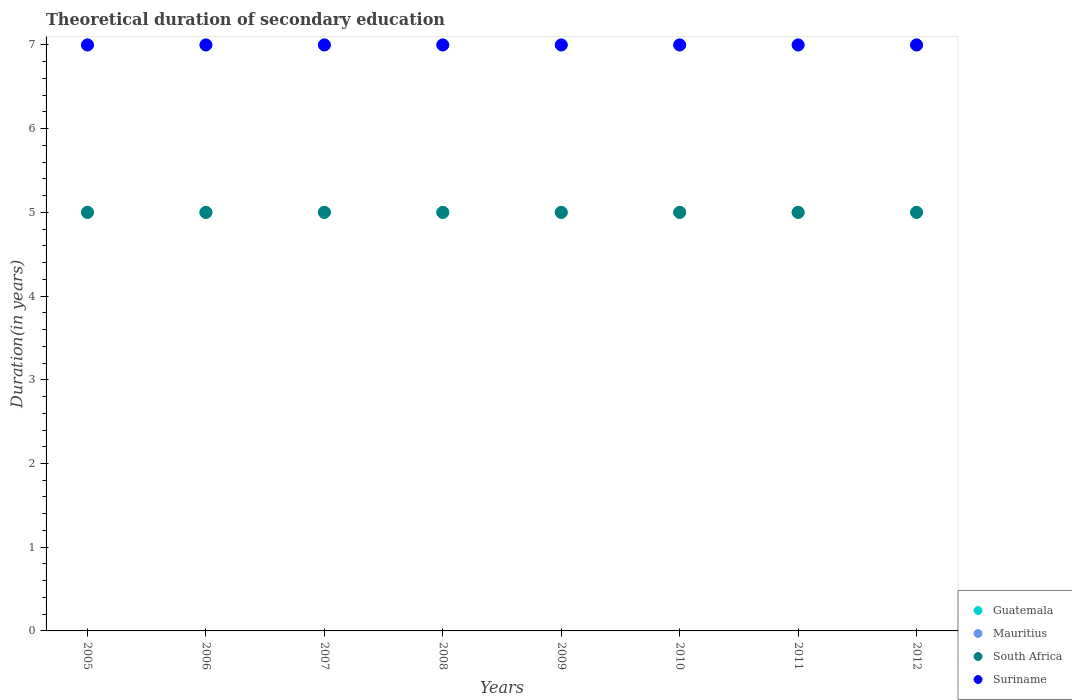What is the total theoretical duration of secondary education in Mauritius in 2012?
Provide a succinct answer. 7. Across all years, what is the maximum total theoretical duration of secondary education in Guatemala?
Make the answer very short. 5. Across all years, what is the minimum total theoretical duration of secondary education in Suriname?
Keep it short and to the point. 7. In which year was the total theoretical duration of secondary education in South Africa maximum?
Provide a succinct answer. 2005. What is the total total theoretical duration of secondary education in Guatemala in the graph?
Your answer should be very brief. 40. What is the difference between the total theoretical duration of secondary education in Guatemala in 2012 and the total theoretical duration of secondary education in Mauritius in 2009?
Ensure brevity in your answer.  -2. In the year 2011, what is the difference between the total theoretical duration of secondary education in Mauritius and total theoretical duration of secondary education in Guatemala?
Keep it short and to the point. 2. In how many years, is the total theoretical duration of secondary education in South Africa greater than 5.8 years?
Keep it short and to the point. 0. What is the ratio of the total theoretical duration of secondary education in Mauritius in 2005 to that in 2007?
Provide a succinct answer. 1. Is the total theoretical duration of secondary education in Guatemala in 2006 less than that in 2010?
Your answer should be compact. No. Is the difference between the total theoretical duration of secondary education in Mauritius in 2008 and 2009 greater than the difference between the total theoretical duration of secondary education in Guatemala in 2008 and 2009?
Keep it short and to the point. No. What is the difference between the highest and the second highest total theoretical duration of secondary education in Suriname?
Offer a terse response. 0. What is the difference between the highest and the lowest total theoretical duration of secondary education in Suriname?
Keep it short and to the point. 0. Is it the case that in every year, the sum of the total theoretical duration of secondary education in Suriname and total theoretical duration of secondary education in South Africa  is greater than the sum of total theoretical duration of secondary education in Mauritius and total theoretical duration of secondary education in Guatemala?
Give a very brief answer. Yes. Does the total theoretical duration of secondary education in South Africa monotonically increase over the years?
Your response must be concise. No. Is the total theoretical duration of secondary education in South Africa strictly less than the total theoretical duration of secondary education in Guatemala over the years?
Offer a terse response. No. How many dotlines are there?
Keep it short and to the point. 4. Are the values on the major ticks of Y-axis written in scientific E-notation?
Your answer should be compact. No. Where does the legend appear in the graph?
Your answer should be very brief. Bottom right. How many legend labels are there?
Your response must be concise. 4. How are the legend labels stacked?
Your response must be concise. Vertical. What is the title of the graph?
Ensure brevity in your answer.  Theoretical duration of secondary education. What is the label or title of the X-axis?
Give a very brief answer. Years. What is the label or title of the Y-axis?
Provide a succinct answer. Duration(in years). What is the Duration(in years) of Guatemala in 2005?
Keep it short and to the point. 5. What is the Duration(in years) of Guatemala in 2006?
Ensure brevity in your answer.  5. What is the Duration(in years) of Guatemala in 2007?
Ensure brevity in your answer.  5. What is the Duration(in years) of Mauritius in 2008?
Keep it short and to the point. 7. What is the Duration(in years) of South Africa in 2008?
Offer a very short reply. 5. What is the Duration(in years) of Guatemala in 2009?
Your response must be concise. 5. What is the Duration(in years) in South Africa in 2010?
Give a very brief answer. 5. What is the Duration(in years) of Guatemala in 2011?
Your response must be concise. 5. What is the Duration(in years) of South Africa in 2011?
Provide a succinct answer. 5. What is the Duration(in years) of Guatemala in 2012?
Your answer should be very brief. 5. What is the Duration(in years) in Mauritius in 2012?
Your answer should be compact. 7. Across all years, what is the maximum Duration(in years) in Guatemala?
Ensure brevity in your answer.  5. Across all years, what is the maximum Duration(in years) in Suriname?
Your answer should be compact. 7. Across all years, what is the minimum Duration(in years) in Guatemala?
Make the answer very short. 5. Across all years, what is the minimum Duration(in years) of Mauritius?
Ensure brevity in your answer.  7. Across all years, what is the minimum Duration(in years) of South Africa?
Provide a succinct answer. 5. What is the total Duration(in years) in Guatemala in the graph?
Offer a very short reply. 40. What is the total Duration(in years) of Mauritius in the graph?
Provide a succinct answer. 56. What is the total Duration(in years) in South Africa in the graph?
Offer a terse response. 40. What is the total Duration(in years) of Suriname in the graph?
Keep it short and to the point. 56. What is the difference between the Duration(in years) in Guatemala in 2005 and that in 2006?
Provide a short and direct response. 0. What is the difference between the Duration(in years) in Mauritius in 2005 and that in 2006?
Your answer should be compact. 0. What is the difference between the Duration(in years) of South Africa in 2005 and that in 2006?
Your response must be concise. 0. What is the difference between the Duration(in years) in Suriname in 2005 and that in 2006?
Provide a short and direct response. 0. What is the difference between the Duration(in years) in Guatemala in 2005 and that in 2007?
Your response must be concise. 0. What is the difference between the Duration(in years) of Mauritius in 2005 and that in 2007?
Offer a terse response. 0. What is the difference between the Duration(in years) in South Africa in 2005 and that in 2008?
Give a very brief answer. 0. What is the difference between the Duration(in years) of Suriname in 2005 and that in 2008?
Offer a very short reply. 0. What is the difference between the Duration(in years) in Guatemala in 2005 and that in 2009?
Keep it short and to the point. 0. What is the difference between the Duration(in years) in South Africa in 2005 and that in 2009?
Provide a short and direct response. 0. What is the difference between the Duration(in years) of Suriname in 2005 and that in 2009?
Give a very brief answer. 0. What is the difference between the Duration(in years) in Suriname in 2005 and that in 2010?
Your answer should be compact. 0. What is the difference between the Duration(in years) in South Africa in 2005 and that in 2011?
Provide a succinct answer. 0. What is the difference between the Duration(in years) of Mauritius in 2005 and that in 2012?
Offer a terse response. 0. What is the difference between the Duration(in years) of Suriname in 2005 and that in 2012?
Offer a very short reply. 0. What is the difference between the Duration(in years) of Guatemala in 2006 and that in 2007?
Your answer should be very brief. 0. What is the difference between the Duration(in years) of South Africa in 2006 and that in 2007?
Make the answer very short. 0. What is the difference between the Duration(in years) of Suriname in 2006 and that in 2007?
Ensure brevity in your answer.  0. What is the difference between the Duration(in years) of Guatemala in 2006 and that in 2008?
Offer a terse response. 0. What is the difference between the Duration(in years) in Mauritius in 2006 and that in 2008?
Ensure brevity in your answer.  0. What is the difference between the Duration(in years) in Suriname in 2006 and that in 2008?
Ensure brevity in your answer.  0. What is the difference between the Duration(in years) in Guatemala in 2006 and that in 2009?
Provide a succinct answer. 0. What is the difference between the Duration(in years) in South Africa in 2006 and that in 2009?
Your answer should be very brief. 0. What is the difference between the Duration(in years) in Suriname in 2006 and that in 2009?
Ensure brevity in your answer.  0. What is the difference between the Duration(in years) in Suriname in 2006 and that in 2010?
Provide a short and direct response. 0. What is the difference between the Duration(in years) in Guatemala in 2006 and that in 2011?
Keep it short and to the point. 0. What is the difference between the Duration(in years) of Mauritius in 2006 and that in 2011?
Offer a terse response. 0. What is the difference between the Duration(in years) of South Africa in 2006 and that in 2011?
Offer a very short reply. 0. What is the difference between the Duration(in years) of Suriname in 2006 and that in 2011?
Your answer should be very brief. 0. What is the difference between the Duration(in years) in Guatemala in 2006 and that in 2012?
Offer a very short reply. 0. What is the difference between the Duration(in years) in Suriname in 2006 and that in 2012?
Provide a short and direct response. 0. What is the difference between the Duration(in years) in Guatemala in 2007 and that in 2008?
Your response must be concise. 0. What is the difference between the Duration(in years) in Mauritius in 2007 and that in 2008?
Give a very brief answer. 0. What is the difference between the Duration(in years) in Suriname in 2007 and that in 2008?
Ensure brevity in your answer.  0. What is the difference between the Duration(in years) of Guatemala in 2007 and that in 2010?
Your answer should be compact. 0. What is the difference between the Duration(in years) in Mauritius in 2007 and that in 2010?
Your response must be concise. 0. What is the difference between the Duration(in years) in Suriname in 2007 and that in 2011?
Keep it short and to the point. 0. What is the difference between the Duration(in years) in Guatemala in 2007 and that in 2012?
Keep it short and to the point. 0. What is the difference between the Duration(in years) of Suriname in 2007 and that in 2012?
Offer a terse response. 0. What is the difference between the Duration(in years) of Guatemala in 2008 and that in 2009?
Your answer should be compact. 0. What is the difference between the Duration(in years) of Mauritius in 2008 and that in 2009?
Offer a terse response. 0. What is the difference between the Duration(in years) of South Africa in 2008 and that in 2009?
Provide a succinct answer. 0. What is the difference between the Duration(in years) in Guatemala in 2008 and that in 2010?
Your answer should be compact. 0. What is the difference between the Duration(in years) of Mauritius in 2008 and that in 2010?
Make the answer very short. 0. What is the difference between the Duration(in years) in Mauritius in 2008 and that in 2011?
Keep it short and to the point. 0. What is the difference between the Duration(in years) of South Africa in 2008 and that in 2011?
Your answer should be compact. 0. What is the difference between the Duration(in years) of Guatemala in 2008 and that in 2012?
Your answer should be very brief. 0. What is the difference between the Duration(in years) of South Africa in 2008 and that in 2012?
Offer a very short reply. 0. What is the difference between the Duration(in years) in Suriname in 2008 and that in 2012?
Your response must be concise. 0. What is the difference between the Duration(in years) in Mauritius in 2009 and that in 2010?
Provide a succinct answer. 0. What is the difference between the Duration(in years) in South Africa in 2009 and that in 2010?
Give a very brief answer. 0. What is the difference between the Duration(in years) in Guatemala in 2009 and that in 2011?
Make the answer very short. 0. What is the difference between the Duration(in years) of Mauritius in 2009 and that in 2011?
Give a very brief answer. 0. What is the difference between the Duration(in years) in Suriname in 2009 and that in 2011?
Offer a very short reply. 0. What is the difference between the Duration(in years) in South Africa in 2009 and that in 2012?
Offer a very short reply. 0. What is the difference between the Duration(in years) of Suriname in 2009 and that in 2012?
Provide a succinct answer. 0. What is the difference between the Duration(in years) of Guatemala in 2010 and that in 2011?
Keep it short and to the point. 0. What is the difference between the Duration(in years) of Mauritius in 2010 and that in 2011?
Your answer should be very brief. 0. What is the difference between the Duration(in years) in Mauritius in 2010 and that in 2012?
Offer a very short reply. 0. What is the difference between the Duration(in years) in Guatemala in 2011 and that in 2012?
Provide a short and direct response. 0. What is the difference between the Duration(in years) in South Africa in 2011 and that in 2012?
Give a very brief answer. 0. What is the difference between the Duration(in years) of Suriname in 2011 and that in 2012?
Offer a very short reply. 0. What is the difference between the Duration(in years) of Guatemala in 2005 and the Duration(in years) of Mauritius in 2006?
Ensure brevity in your answer.  -2. What is the difference between the Duration(in years) of Guatemala in 2005 and the Duration(in years) of Suriname in 2006?
Give a very brief answer. -2. What is the difference between the Duration(in years) in Mauritius in 2005 and the Duration(in years) in South Africa in 2006?
Make the answer very short. 2. What is the difference between the Duration(in years) of Mauritius in 2005 and the Duration(in years) of Suriname in 2006?
Give a very brief answer. 0. What is the difference between the Duration(in years) in South Africa in 2005 and the Duration(in years) in Suriname in 2006?
Make the answer very short. -2. What is the difference between the Duration(in years) in Guatemala in 2005 and the Duration(in years) in Mauritius in 2007?
Your answer should be very brief. -2. What is the difference between the Duration(in years) of Guatemala in 2005 and the Duration(in years) of Suriname in 2007?
Give a very brief answer. -2. What is the difference between the Duration(in years) of South Africa in 2005 and the Duration(in years) of Suriname in 2007?
Provide a short and direct response. -2. What is the difference between the Duration(in years) in South Africa in 2005 and the Duration(in years) in Suriname in 2008?
Provide a short and direct response. -2. What is the difference between the Duration(in years) of Guatemala in 2005 and the Duration(in years) of Mauritius in 2009?
Your response must be concise. -2. What is the difference between the Duration(in years) in Guatemala in 2005 and the Duration(in years) in South Africa in 2009?
Make the answer very short. 0. What is the difference between the Duration(in years) of Guatemala in 2005 and the Duration(in years) of Suriname in 2009?
Make the answer very short. -2. What is the difference between the Duration(in years) in Mauritius in 2005 and the Duration(in years) in Suriname in 2009?
Provide a short and direct response. 0. What is the difference between the Duration(in years) of Guatemala in 2005 and the Duration(in years) of Mauritius in 2010?
Give a very brief answer. -2. What is the difference between the Duration(in years) of Mauritius in 2005 and the Duration(in years) of Suriname in 2010?
Keep it short and to the point. 0. What is the difference between the Duration(in years) in South Africa in 2005 and the Duration(in years) in Suriname in 2010?
Provide a short and direct response. -2. What is the difference between the Duration(in years) in Guatemala in 2005 and the Duration(in years) in Mauritius in 2011?
Ensure brevity in your answer.  -2. What is the difference between the Duration(in years) of Mauritius in 2005 and the Duration(in years) of South Africa in 2011?
Keep it short and to the point. 2. What is the difference between the Duration(in years) in South Africa in 2005 and the Duration(in years) in Suriname in 2011?
Offer a very short reply. -2. What is the difference between the Duration(in years) of Guatemala in 2005 and the Duration(in years) of Mauritius in 2012?
Your answer should be very brief. -2. What is the difference between the Duration(in years) in Mauritius in 2005 and the Duration(in years) in South Africa in 2012?
Your answer should be compact. 2. What is the difference between the Duration(in years) in South Africa in 2005 and the Duration(in years) in Suriname in 2012?
Offer a terse response. -2. What is the difference between the Duration(in years) of Guatemala in 2006 and the Duration(in years) of Mauritius in 2007?
Offer a terse response. -2. What is the difference between the Duration(in years) in Mauritius in 2006 and the Duration(in years) in South Africa in 2007?
Your answer should be very brief. 2. What is the difference between the Duration(in years) in Guatemala in 2006 and the Duration(in years) in Mauritius in 2008?
Offer a terse response. -2. What is the difference between the Duration(in years) of Guatemala in 2006 and the Duration(in years) of South Africa in 2008?
Offer a terse response. 0. What is the difference between the Duration(in years) of Guatemala in 2006 and the Duration(in years) of Suriname in 2008?
Offer a terse response. -2. What is the difference between the Duration(in years) in Mauritius in 2006 and the Duration(in years) in South Africa in 2008?
Your answer should be compact. 2. What is the difference between the Duration(in years) in Mauritius in 2006 and the Duration(in years) in Suriname in 2008?
Offer a very short reply. 0. What is the difference between the Duration(in years) of South Africa in 2006 and the Duration(in years) of Suriname in 2008?
Your answer should be compact. -2. What is the difference between the Duration(in years) in Guatemala in 2006 and the Duration(in years) in South Africa in 2009?
Your answer should be compact. 0. What is the difference between the Duration(in years) in Guatemala in 2006 and the Duration(in years) in Suriname in 2009?
Your answer should be very brief. -2. What is the difference between the Duration(in years) in Mauritius in 2006 and the Duration(in years) in South Africa in 2009?
Ensure brevity in your answer.  2. What is the difference between the Duration(in years) in Mauritius in 2006 and the Duration(in years) in Suriname in 2009?
Provide a short and direct response. 0. What is the difference between the Duration(in years) in Guatemala in 2006 and the Duration(in years) in Mauritius in 2010?
Offer a terse response. -2. What is the difference between the Duration(in years) in Guatemala in 2006 and the Duration(in years) in South Africa in 2010?
Provide a short and direct response. 0. What is the difference between the Duration(in years) in Guatemala in 2006 and the Duration(in years) in Suriname in 2010?
Your answer should be very brief. -2. What is the difference between the Duration(in years) in Mauritius in 2006 and the Duration(in years) in Suriname in 2010?
Offer a terse response. 0. What is the difference between the Duration(in years) in Guatemala in 2006 and the Duration(in years) in South Africa in 2011?
Make the answer very short. 0. What is the difference between the Duration(in years) in Guatemala in 2006 and the Duration(in years) in Suriname in 2011?
Make the answer very short. -2. What is the difference between the Duration(in years) in Mauritius in 2006 and the Duration(in years) in South Africa in 2011?
Provide a succinct answer. 2. What is the difference between the Duration(in years) of Guatemala in 2006 and the Duration(in years) of South Africa in 2012?
Give a very brief answer. 0. What is the difference between the Duration(in years) of Guatemala in 2006 and the Duration(in years) of Suriname in 2012?
Provide a short and direct response. -2. What is the difference between the Duration(in years) of Mauritius in 2006 and the Duration(in years) of South Africa in 2012?
Provide a succinct answer. 2. What is the difference between the Duration(in years) of Guatemala in 2007 and the Duration(in years) of South Africa in 2008?
Keep it short and to the point. 0. What is the difference between the Duration(in years) of Mauritius in 2007 and the Duration(in years) of South Africa in 2008?
Your answer should be compact. 2. What is the difference between the Duration(in years) in South Africa in 2007 and the Duration(in years) in Suriname in 2008?
Your response must be concise. -2. What is the difference between the Duration(in years) of Guatemala in 2007 and the Duration(in years) of South Africa in 2009?
Ensure brevity in your answer.  0. What is the difference between the Duration(in years) in Guatemala in 2007 and the Duration(in years) in Suriname in 2009?
Offer a terse response. -2. What is the difference between the Duration(in years) of South Africa in 2007 and the Duration(in years) of Suriname in 2009?
Your answer should be compact. -2. What is the difference between the Duration(in years) of Guatemala in 2007 and the Duration(in years) of Suriname in 2010?
Your answer should be compact. -2. What is the difference between the Duration(in years) of Mauritius in 2007 and the Duration(in years) of South Africa in 2010?
Offer a terse response. 2. What is the difference between the Duration(in years) in South Africa in 2007 and the Duration(in years) in Suriname in 2010?
Ensure brevity in your answer.  -2. What is the difference between the Duration(in years) in Guatemala in 2007 and the Duration(in years) in South Africa in 2011?
Make the answer very short. 0. What is the difference between the Duration(in years) in Mauritius in 2007 and the Duration(in years) in South Africa in 2011?
Make the answer very short. 2. What is the difference between the Duration(in years) in Mauritius in 2007 and the Duration(in years) in Suriname in 2011?
Offer a terse response. 0. What is the difference between the Duration(in years) in South Africa in 2007 and the Duration(in years) in Suriname in 2011?
Your answer should be compact. -2. What is the difference between the Duration(in years) in Guatemala in 2007 and the Duration(in years) in Mauritius in 2012?
Give a very brief answer. -2. What is the difference between the Duration(in years) of Guatemala in 2007 and the Duration(in years) of South Africa in 2012?
Keep it short and to the point. 0. What is the difference between the Duration(in years) of Guatemala in 2007 and the Duration(in years) of Suriname in 2012?
Offer a very short reply. -2. What is the difference between the Duration(in years) of Guatemala in 2008 and the Duration(in years) of South Africa in 2009?
Make the answer very short. 0. What is the difference between the Duration(in years) in Guatemala in 2008 and the Duration(in years) in Mauritius in 2010?
Provide a succinct answer. -2. What is the difference between the Duration(in years) in Mauritius in 2008 and the Duration(in years) in Suriname in 2010?
Ensure brevity in your answer.  0. What is the difference between the Duration(in years) in Guatemala in 2008 and the Duration(in years) in South Africa in 2011?
Offer a terse response. 0. What is the difference between the Duration(in years) of Mauritius in 2008 and the Duration(in years) of Suriname in 2011?
Provide a short and direct response. 0. What is the difference between the Duration(in years) of South Africa in 2008 and the Duration(in years) of Suriname in 2011?
Your answer should be compact. -2. What is the difference between the Duration(in years) in Guatemala in 2008 and the Duration(in years) in Mauritius in 2012?
Your response must be concise. -2. What is the difference between the Duration(in years) in South Africa in 2008 and the Duration(in years) in Suriname in 2012?
Give a very brief answer. -2. What is the difference between the Duration(in years) in Guatemala in 2009 and the Duration(in years) in South Africa in 2010?
Provide a succinct answer. 0. What is the difference between the Duration(in years) of Guatemala in 2009 and the Duration(in years) of Suriname in 2010?
Keep it short and to the point. -2. What is the difference between the Duration(in years) of Mauritius in 2009 and the Duration(in years) of South Africa in 2010?
Make the answer very short. 2. What is the difference between the Duration(in years) of South Africa in 2009 and the Duration(in years) of Suriname in 2010?
Provide a succinct answer. -2. What is the difference between the Duration(in years) in Guatemala in 2009 and the Duration(in years) in Mauritius in 2011?
Your response must be concise. -2. What is the difference between the Duration(in years) of Guatemala in 2009 and the Duration(in years) of Suriname in 2011?
Your answer should be very brief. -2. What is the difference between the Duration(in years) of Mauritius in 2009 and the Duration(in years) of Suriname in 2011?
Offer a terse response. 0. What is the difference between the Duration(in years) of Guatemala in 2009 and the Duration(in years) of Mauritius in 2012?
Your response must be concise. -2. What is the difference between the Duration(in years) in Guatemala in 2009 and the Duration(in years) in Suriname in 2012?
Provide a succinct answer. -2. What is the difference between the Duration(in years) of Mauritius in 2009 and the Duration(in years) of Suriname in 2012?
Provide a short and direct response. 0. What is the difference between the Duration(in years) of Guatemala in 2010 and the Duration(in years) of South Africa in 2011?
Your response must be concise. 0. What is the difference between the Duration(in years) in Mauritius in 2010 and the Duration(in years) in Suriname in 2011?
Give a very brief answer. 0. What is the difference between the Duration(in years) in Guatemala in 2010 and the Duration(in years) in Mauritius in 2012?
Your answer should be compact. -2. What is the difference between the Duration(in years) of Guatemala in 2010 and the Duration(in years) of South Africa in 2012?
Ensure brevity in your answer.  0. What is the difference between the Duration(in years) in Guatemala in 2010 and the Duration(in years) in Suriname in 2012?
Offer a very short reply. -2. What is the difference between the Duration(in years) in South Africa in 2010 and the Duration(in years) in Suriname in 2012?
Keep it short and to the point. -2. What is the difference between the Duration(in years) in Mauritius in 2011 and the Duration(in years) in Suriname in 2012?
Your answer should be very brief. 0. What is the average Duration(in years) of Guatemala per year?
Provide a short and direct response. 5. What is the average Duration(in years) in Mauritius per year?
Provide a short and direct response. 7. What is the average Duration(in years) of Suriname per year?
Make the answer very short. 7. In the year 2005, what is the difference between the Duration(in years) of Guatemala and Duration(in years) of Mauritius?
Keep it short and to the point. -2. In the year 2005, what is the difference between the Duration(in years) in Guatemala and Duration(in years) in Suriname?
Provide a succinct answer. -2. In the year 2006, what is the difference between the Duration(in years) in Mauritius and Duration(in years) in South Africa?
Keep it short and to the point. 2. In the year 2006, what is the difference between the Duration(in years) in South Africa and Duration(in years) in Suriname?
Keep it short and to the point. -2. In the year 2007, what is the difference between the Duration(in years) of Guatemala and Duration(in years) of Mauritius?
Your answer should be compact. -2. In the year 2007, what is the difference between the Duration(in years) in Guatemala and Duration(in years) in South Africa?
Your response must be concise. 0. In the year 2007, what is the difference between the Duration(in years) in Guatemala and Duration(in years) in Suriname?
Your response must be concise. -2. In the year 2007, what is the difference between the Duration(in years) of Mauritius and Duration(in years) of South Africa?
Ensure brevity in your answer.  2. In the year 2007, what is the difference between the Duration(in years) of Mauritius and Duration(in years) of Suriname?
Ensure brevity in your answer.  0. In the year 2008, what is the difference between the Duration(in years) in Mauritius and Duration(in years) in South Africa?
Give a very brief answer. 2. In the year 2008, what is the difference between the Duration(in years) in South Africa and Duration(in years) in Suriname?
Offer a very short reply. -2. In the year 2009, what is the difference between the Duration(in years) in Guatemala and Duration(in years) in Mauritius?
Provide a succinct answer. -2. In the year 2009, what is the difference between the Duration(in years) of Guatemala and Duration(in years) of Suriname?
Offer a very short reply. -2. In the year 2009, what is the difference between the Duration(in years) of Mauritius and Duration(in years) of Suriname?
Ensure brevity in your answer.  0. In the year 2009, what is the difference between the Duration(in years) in South Africa and Duration(in years) in Suriname?
Give a very brief answer. -2. In the year 2010, what is the difference between the Duration(in years) of Guatemala and Duration(in years) of Mauritius?
Ensure brevity in your answer.  -2. In the year 2010, what is the difference between the Duration(in years) in Mauritius and Duration(in years) in South Africa?
Keep it short and to the point. 2. In the year 2010, what is the difference between the Duration(in years) in Mauritius and Duration(in years) in Suriname?
Provide a short and direct response. 0. In the year 2010, what is the difference between the Duration(in years) in South Africa and Duration(in years) in Suriname?
Ensure brevity in your answer.  -2. In the year 2011, what is the difference between the Duration(in years) of Guatemala and Duration(in years) of Mauritius?
Offer a terse response. -2. In the year 2011, what is the difference between the Duration(in years) in Guatemala and Duration(in years) in Suriname?
Offer a terse response. -2. In the year 2011, what is the difference between the Duration(in years) of Mauritius and Duration(in years) of South Africa?
Make the answer very short. 2. In the year 2011, what is the difference between the Duration(in years) of South Africa and Duration(in years) of Suriname?
Provide a short and direct response. -2. In the year 2012, what is the difference between the Duration(in years) in Guatemala and Duration(in years) in South Africa?
Keep it short and to the point. 0. In the year 2012, what is the difference between the Duration(in years) of Mauritius and Duration(in years) of Suriname?
Give a very brief answer. 0. What is the ratio of the Duration(in years) in Guatemala in 2005 to that in 2007?
Provide a succinct answer. 1. What is the ratio of the Duration(in years) in Mauritius in 2005 to that in 2007?
Make the answer very short. 1. What is the ratio of the Duration(in years) in South Africa in 2005 to that in 2007?
Provide a succinct answer. 1. What is the ratio of the Duration(in years) of Suriname in 2005 to that in 2007?
Keep it short and to the point. 1. What is the ratio of the Duration(in years) of Guatemala in 2005 to that in 2008?
Provide a short and direct response. 1. What is the ratio of the Duration(in years) in Mauritius in 2005 to that in 2008?
Your answer should be very brief. 1. What is the ratio of the Duration(in years) in South Africa in 2005 to that in 2008?
Your response must be concise. 1. What is the ratio of the Duration(in years) in Suriname in 2005 to that in 2009?
Your answer should be very brief. 1. What is the ratio of the Duration(in years) of South Africa in 2005 to that in 2011?
Provide a succinct answer. 1. What is the ratio of the Duration(in years) of Suriname in 2005 to that in 2011?
Offer a very short reply. 1. What is the ratio of the Duration(in years) in Mauritius in 2005 to that in 2012?
Provide a short and direct response. 1. What is the ratio of the Duration(in years) of South Africa in 2005 to that in 2012?
Ensure brevity in your answer.  1. What is the ratio of the Duration(in years) in South Africa in 2006 to that in 2007?
Give a very brief answer. 1. What is the ratio of the Duration(in years) in Suriname in 2006 to that in 2007?
Give a very brief answer. 1. What is the ratio of the Duration(in years) of Mauritius in 2006 to that in 2008?
Ensure brevity in your answer.  1. What is the ratio of the Duration(in years) in Suriname in 2006 to that in 2008?
Your answer should be very brief. 1. What is the ratio of the Duration(in years) in Guatemala in 2006 to that in 2009?
Your response must be concise. 1. What is the ratio of the Duration(in years) in Guatemala in 2006 to that in 2010?
Offer a very short reply. 1. What is the ratio of the Duration(in years) of Mauritius in 2006 to that in 2010?
Your answer should be compact. 1. What is the ratio of the Duration(in years) in Suriname in 2006 to that in 2010?
Your answer should be compact. 1. What is the ratio of the Duration(in years) of Mauritius in 2006 to that in 2011?
Your response must be concise. 1. What is the ratio of the Duration(in years) of South Africa in 2006 to that in 2012?
Your response must be concise. 1. What is the ratio of the Duration(in years) of Suriname in 2006 to that in 2012?
Your answer should be compact. 1. What is the ratio of the Duration(in years) of Mauritius in 2007 to that in 2008?
Provide a succinct answer. 1. What is the ratio of the Duration(in years) in South Africa in 2007 to that in 2008?
Your response must be concise. 1. What is the ratio of the Duration(in years) in Guatemala in 2007 to that in 2009?
Offer a very short reply. 1. What is the ratio of the Duration(in years) of Mauritius in 2007 to that in 2009?
Make the answer very short. 1. What is the ratio of the Duration(in years) in South Africa in 2007 to that in 2009?
Offer a very short reply. 1. What is the ratio of the Duration(in years) in Suriname in 2007 to that in 2009?
Offer a terse response. 1. What is the ratio of the Duration(in years) of Guatemala in 2007 to that in 2010?
Give a very brief answer. 1. What is the ratio of the Duration(in years) of Mauritius in 2007 to that in 2010?
Provide a short and direct response. 1. What is the ratio of the Duration(in years) in Mauritius in 2007 to that in 2011?
Offer a very short reply. 1. What is the ratio of the Duration(in years) in Guatemala in 2007 to that in 2012?
Your answer should be compact. 1. What is the ratio of the Duration(in years) in Guatemala in 2008 to that in 2009?
Keep it short and to the point. 1. What is the ratio of the Duration(in years) of Mauritius in 2008 to that in 2010?
Provide a short and direct response. 1. What is the ratio of the Duration(in years) in Suriname in 2008 to that in 2010?
Provide a succinct answer. 1. What is the ratio of the Duration(in years) in Suriname in 2008 to that in 2011?
Provide a succinct answer. 1. What is the ratio of the Duration(in years) in South Africa in 2008 to that in 2012?
Your answer should be compact. 1. What is the ratio of the Duration(in years) in Guatemala in 2009 to that in 2010?
Keep it short and to the point. 1. What is the ratio of the Duration(in years) in Mauritius in 2009 to that in 2010?
Your answer should be very brief. 1. What is the ratio of the Duration(in years) of South Africa in 2009 to that in 2010?
Provide a succinct answer. 1. What is the ratio of the Duration(in years) in Guatemala in 2009 to that in 2011?
Ensure brevity in your answer.  1. What is the ratio of the Duration(in years) of Mauritius in 2009 to that in 2011?
Offer a terse response. 1. What is the ratio of the Duration(in years) of South Africa in 2009 to that in 2011?
Provide a succinct answer. 1. What is the ratio of the Duration(in years) of Suriname in 2009 to that in 2011?
Your answer should be very brief. 1. What is the ratio of the Duration(in years) of Guatemala in 2009 to that in 2012?
Your answer should be compact. 1. What is the ratio of the Duration(in years) of Suriname in 2009 to that in 2012?
Provide a succinct answer. 1. What is the ratio of the Duration(in years) of Guatemala in 2010 to that in 2011?
Provide a short and direct response. 1. What is the ratio of the Duration(in years) in South Africa in 2010 to that in 2011?
Give a very brief answer. 1. What is the ratio of the Duration(in years) of Suriname in 2010 to that in 2011?
Provide a short and direct response. 1. What is the ratio of the Duration(in years) in Mauritius in 2010 to that in 2012?
Offer a very short reply. 1. What is the ratio of the Duration(in years) in South Africa in 2010 to that in 2012?
Provide a succinct answer. 1. What is the ratio of the Duration(in years) in Guatemala in 2011 to that in 2012?
Keep it short and to the point. 1. What is the ratio of the Duration(in years) in Mauritius in 2011 to that in 2012?
Offer a very short reply. 1. What is the ratio of the Duration(in years) in South Africa in 2011 to that in 2012?
Offer a terse response. 1. What is the ratio of the Duration(in years) of Suriname in 2011 to that in 2012?
Give a very brief answer. 1. What is the difference between the highest and the second highest Duration(in years) in Guatemala?
Your answer should be compact. 0. What is the difference between the highest and the second highest Duration(in years) in Mauritius?
Your answer should be very brief. 0. What is the difference between the highest and the second highest Duration(in years) of South Africa?
Your answer should be very brief. 0. What is the difference between the highest and the second highest Duration(in years) in Suriname?
Ensure brevity in your answer.  0. What is the difference between the highest and the lowest Duration(in years) of Mauritius?
Your response must be concise. 0. What is the difference between the highest and the lowest Duration(in years) of Suriname?
Provide a short and direct response. 0. 